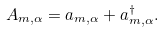<formula> <loc_0><loc_0><loc_500><loc_500>A _ { m , \alpha } = a _ { m , \alpha } + a ^ { \dag } _ { m , \alpha } .</formula> 